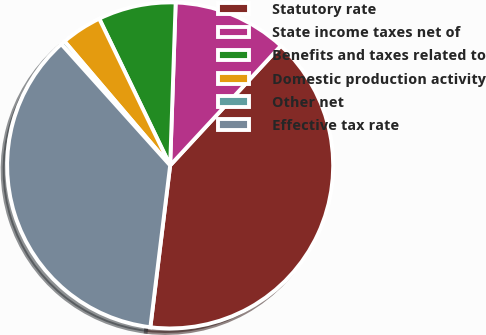Convert chart. <chart><loc_0><loc_0><loc_500><loc_500><pie_chart><fcel>Statutory rate<fcel>State income taxes net of<fcel>Benefits and taxes related to<fcel>Domestic production activity<fcel>Other net<fcel>Effective tax rate<nl><fcel>40.05%<fcel>11.34%<fcel>7.7%<fcel>4.06%<fcel>0.42%<fcel>36.41%<nl></chart> 